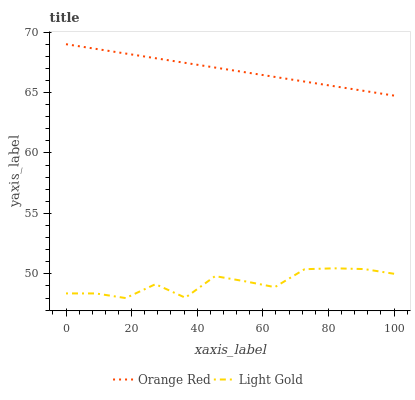Does Light Gold have the minimum area under the curve?
Answer yes or no. Yes. Does Orange Red have the maximum area under the curve?
Answer yes or no. Yes. Does Orange Red have the minimum area under the curve?
Answer yes or no. No. Is Orange Red the smoothest?
Answer yes or no. Yes. Is Light Gold the roughest?
Answer yes or no. Yes. Is Orange Red the roughest?
Answer yes or no. No. Does Light Gold have the lowest value?
Answer yes or no. Yes. Does Orange Red have the lowest value?
Answer yes or no. No. Does Orange Red have the highest value?
Answer yes or no. Yes. Is Light Gold less than Orange Red?
Answer yes or no. Yes. Is Orange Red greater than Light Gold?
Answer yes or no. Yes. Does Light Gold intersect Orange Red?
Answer yes or no. No. 